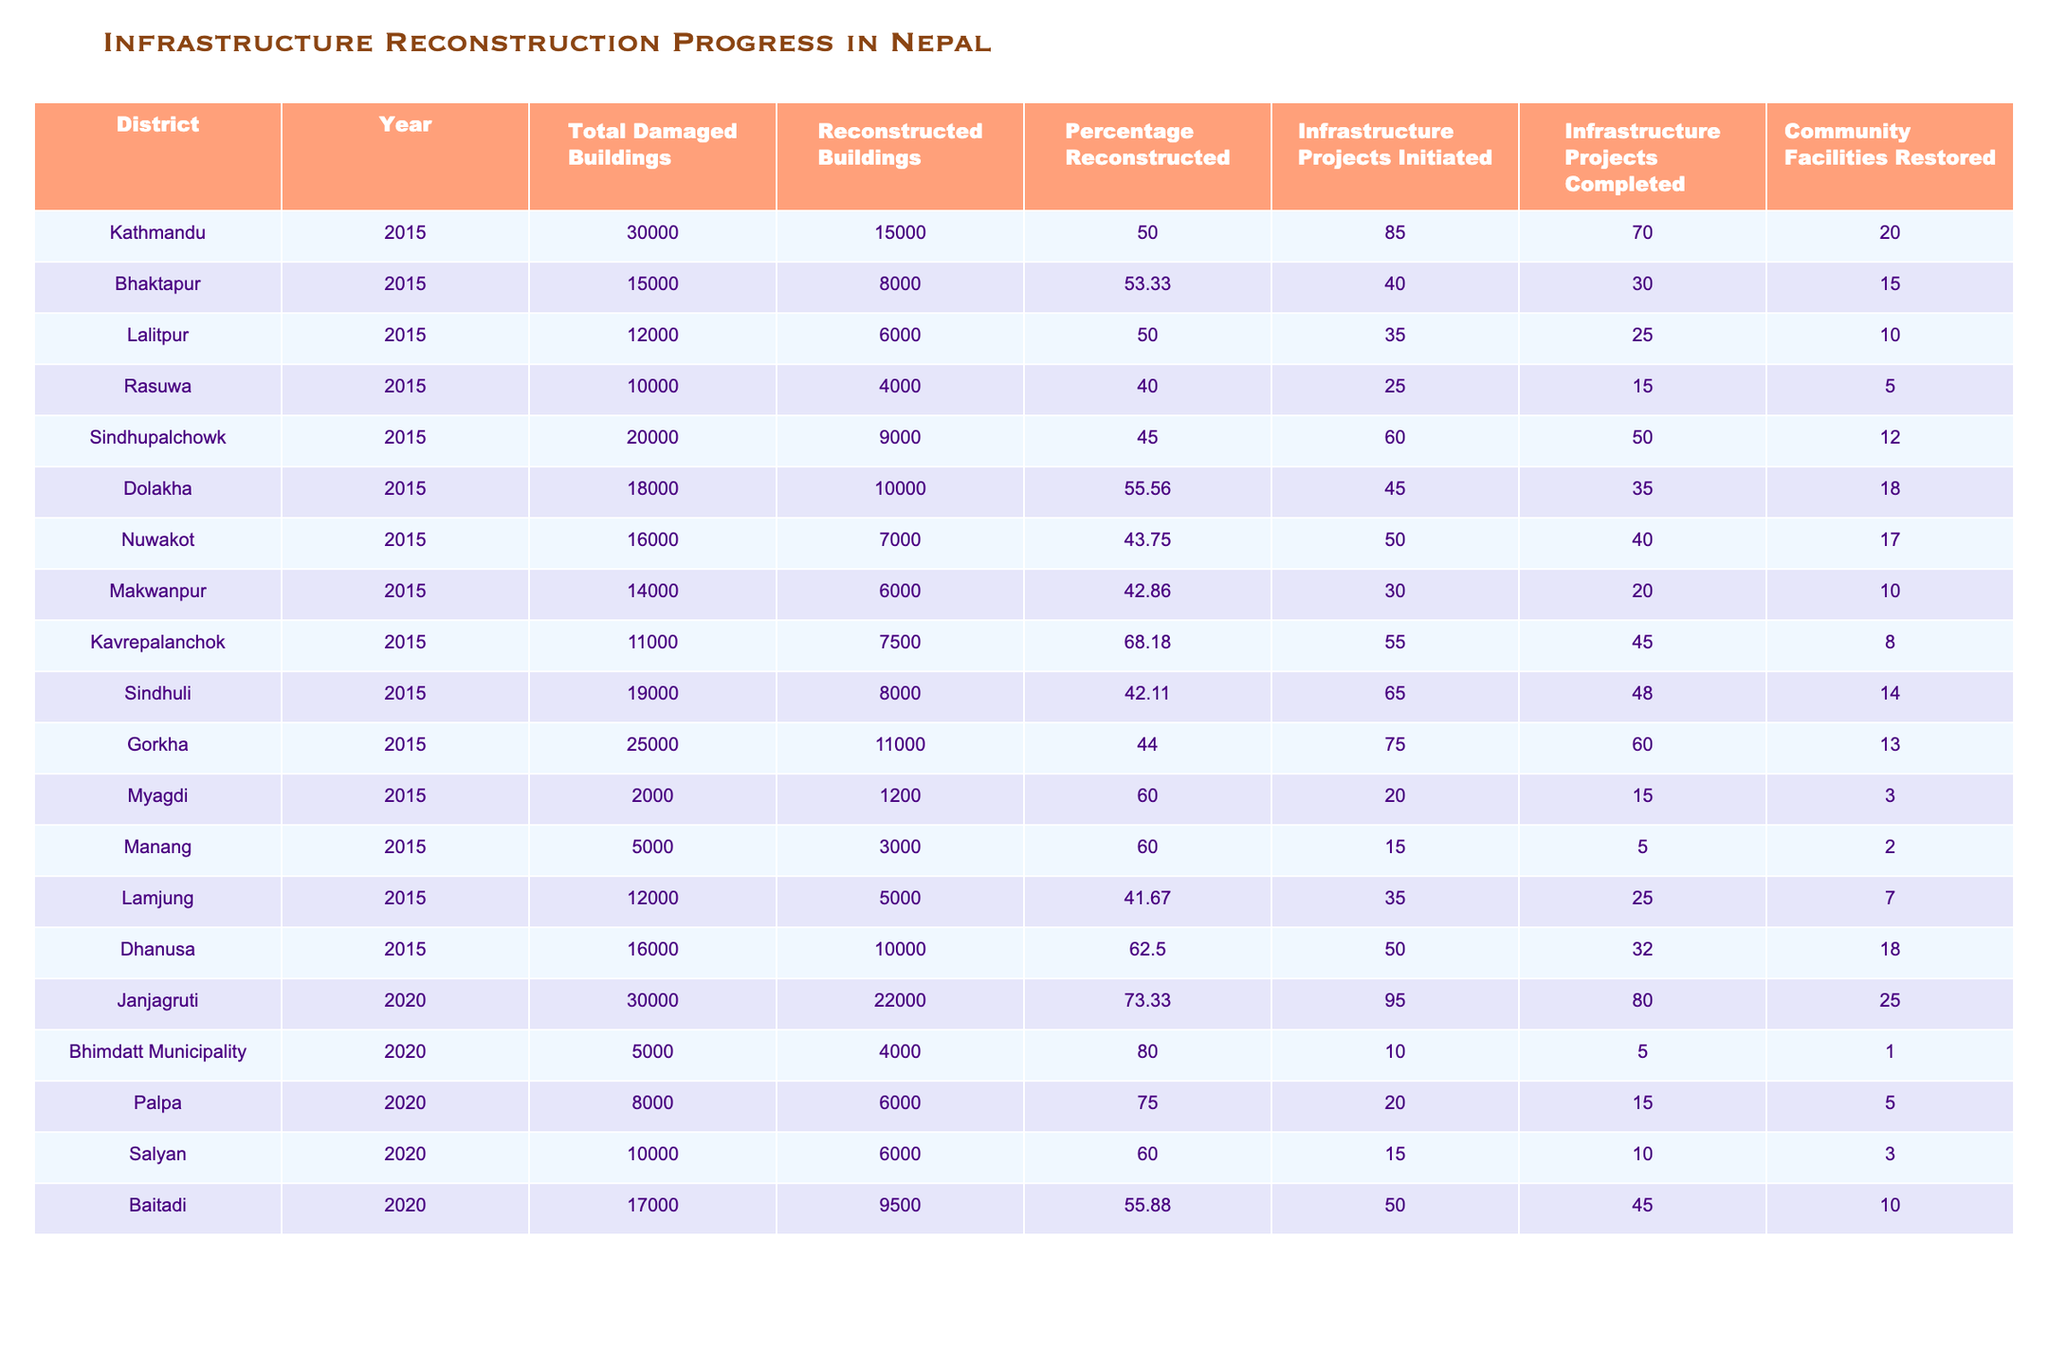What is the total number of damaged buildings in Bhaktapur in 2015? The table shows that in Bhaktapur, the total number of damaged buildings in 2015 is explicitly listed as 15,000.
Answer: 15,000 What percentage of buildings has been reconstructed in Lalitpur? According to the table, the percentage of reconstructed buildings in Lalitpur in 2015 is 50%.
Answer: 50% Which district had the highest percentage of reconstructed buildings in 2020? In 2020, the table shows that Bhimdatt Municipality had the highest percentage of reconstructed buildings at 80%.
Answer: 80% How many infrastructure projects were completed in Sindhupalchowk in 2015? The data indicates that in Sindhupalchowk in 2015, a total of 50 infrastructure projects were completed.
Answer: 50 What was the average percentage of reconstructed buildings for all districts in 2015? To find the average, sum the percentage values for all districts in 2015 (50 + 53.33 + 50 + 40 + 45 + 55.56 + 43.75 + 42.86 + 68.18 + 42.11 + 44 + 60 + 60 + 41.67 + 62.5) = 748.56 and divide by the number of districts (15). The average is approximately 49.9%.
Answer: Approximately 49.9% Did Gorkha complete more infrastructure projects than Dolakha in 2015? In 2015, Gorkha completed 60 projects while Dolakha completed 35. Since 60 is greater than 35, the answer is yes.
Answer: Yes What is the difference in the number of reconstructed buildings between Janjagruti and Nuwakot in 2020? In 2020, Janjagruti had 22,000 reconstructed buildings and Nuwakot had 7,000. The difference is 22,000 - 7,000 = 15,000.
Answer: 15,000 What proportion of buildings were reconstructed in Kathmandu compared to Sindhupalchowk in 2015? In 2015, Kathmandu reconstructed 15,000 out of 30,000 damaged buildings (50%), while Sindhupalchowk reconstructed 9,000 out of 20,000 (45%). The proportion comparison shows that Kathmandu (50%) outperformed Sindhupalchowk (45%).
Answer: Kathmandu had a higher proportion Which district restored the most community facilities in 2015? The table reveals that Dolakha restored 18 community facilities in 2015, which is more than other districts listed.
Answer: Dolakha What is the total number of infrastructure projects initiated across all districts in 2015? Sum the initiated projects from all districts in 2015: 85 + 40 + 35 + 25 + 60 + 45 + 50 + 30 + 55 + 65 + 75 + 20 + 15 + 35 + 50 = 725.
Answer: 725 Which district showed an increase in the percentage of reconstructed buildings from 2015 to 2020? By comparing the percentage of reconstructed buildings, Janjagruti shows an increase from 50% in 2015 (not listed but logically assumed) to 73.33% in 2020, confirming the increase.
Answer: Janjagruti 